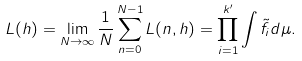<formula> <loc_0><loc_0><loc_500><loc_500>L ( h ) = \lim _ { N \to \infty } \frac { 1 } { N } \sum _ { n = 0 } ^ { N - 1 } L ( n , h ) = \prod _ { i = 1 } ^ { k ^ { \prime } } \int \tilde { f } _ { i } d \mu .</formula> 